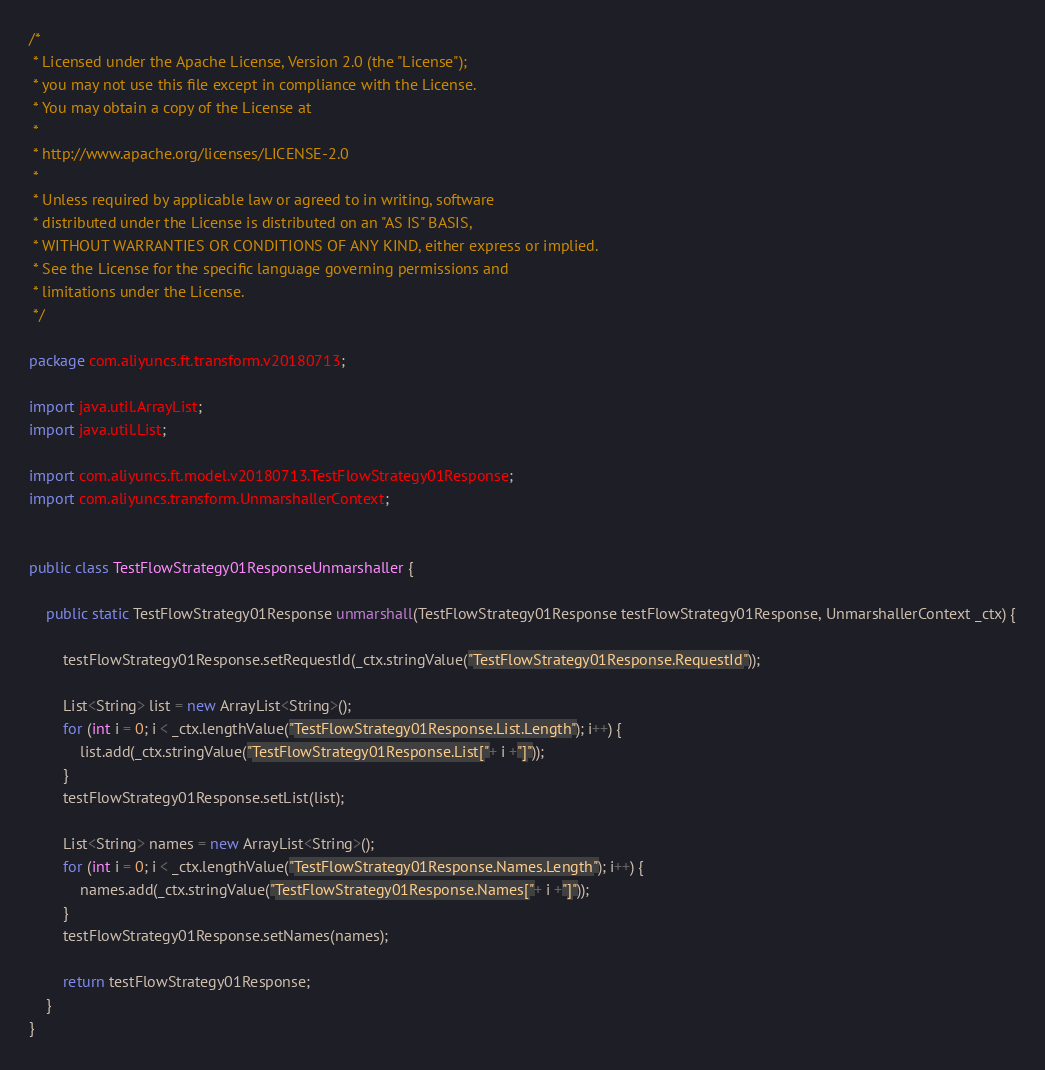Convert code to text. <code><loc_0><loc_0><loc_500><loc_500><_Java_>/*
 * Licensed under the Apache License, Version 2.0 (the "License");
 * you may not use this file except in compliance with the License.
 * You may obtain a copy of the License at
 *
 * http://www.apache.org/licenses/LICENSE-2.0
 *
 * Unless required by applicable law or agreed to in writing, software
 * distributed under the License is distributed on an "AS IS" BASIS,
 * WITHOUT WARRANTIES OR CONDITIONS OF ANY KIND, either express or implied.
 * See the License for the specific language governing permissions and
 * limitations under the License.
 */

package com.aliyuncs.ft.transform.v20180713;

import java.util.ArrayList;
import java.util.List;

import com.aliyuncs.ft.model.v20180713.TestFlowStrategy01Response;
import com.aliyuncs.transform.UnmarshallerContext;


public class TestFlowStrategy01ResponseUnmarshaller {

	public static TestFlowStrategy01Response unmarshall(TestFlowStrategy01Response testFlowStrategy01Response, UnmarshallerContext _ctx) {
		
		testFlowStrategy01Response.setRequestId(_ctx.stringValue("TestFlowStrategy01Response.RequestId"));

		List<String> list = new ArrayList<String>();
		for (int i = 0; i < _ctx.lengthValue("TestFlowStrategy01Response.List.Length"); i++) {
			list.add(_ctx.stringValue("TestFlowStrategy01Response.List["+ i +"]"));
		}
		testFlowStrategy01Response.setList(list);

		List<String> names = new ArrayList<String>();
		for (int i = 0; i < _ctx.lengthValue("TestFlowStrategy01Response.Names.Length"); i++) {
			names.add(_ctx.stringValue("TestFlowStrategy01Response.Names["+ i +"]"));
		}
		testFlowStrategy01Response.setNames(names);
	 
	 	return testFlowStrategy01Response;
	}
}</code> 